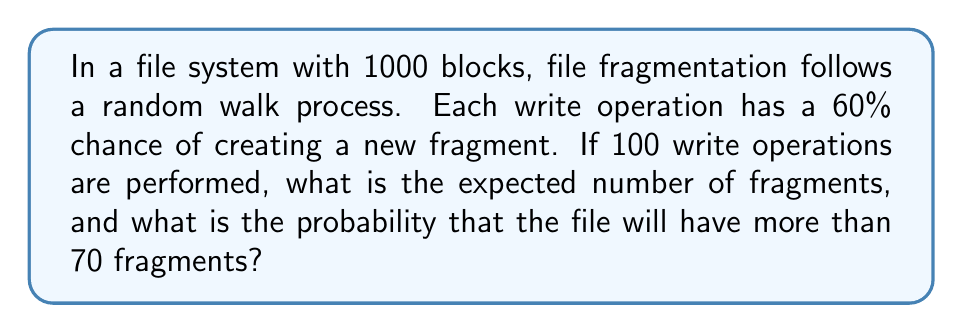Solve this math problem. Let's approach this step-by-step:

1) This scenario can be modeled as a binomial process, where each write operation is a trial, and creating a new fragment is a success.

2) Expected number of fragments:
   Let $X$ be the number of fragments.
   $$E[X] = np$$
   where $n$ is the number of trials (write operations) and $p$ is the probability of success (creating a new fragment).
   
   $$E[X] = 100 \times 0.60 = 60$$

3) To find the probability of having more than 70 fragments, we need to use the cumulative binomial distribution:

   $$P(X > 70) = 1 - P(X \leq 70)$$

4) We can calculate this using the normal approximation to the binomial distribution, as $n$ is large (100) and $np$ and $n(1-p)$ are both greater than 5.

5) The mean of this normal approximation is $\mu = np = 60$, and the standard deviation is $\sigma = \sqrt{np(1-p)} = \sqrt{100 \times 0.60 \times 0.40} = 4.90$

6) We need to find $P(X > 70)$, which is equivalent to $P(Z > \frac{70.5 - 60}{4.90})$ where Z is a standard normal variable. We use 70.5 for continuity correction.

7) $$Z = \frac{70.5 - 60}{4.90} = 2.14$$

8) Using a standard normal table or calculator, we find:
   $$P(Z > 2.14) \approx 0.0162$$

Therefore, the probability of having more than 70 fragments is approximately 0.0162 or 1.62%.
Answer: Expected fragments: 60; Probability of >70 fragments: 0.0162 